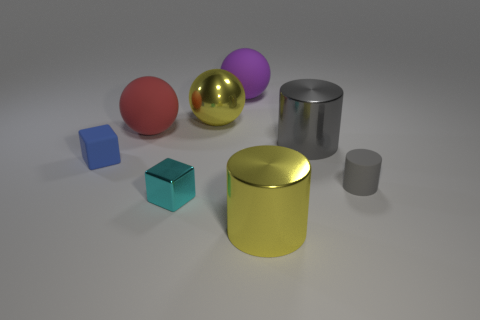Subtract all red balls. How many balls are left? 2 Add 2 tiny brown metal cubes. How many objects exist? 10 Subtract all red balls. How many balls are left? 2 Subtract all brown spheres. How many gray cylinders are left? 2 Subtract all cylinders. How many objects are left? 5 Subtract all purple cylinders. Subtract all green cubes. How many cylinders are left? 3 Subtract all metallic blocks. Subtract all big purple matte objects. How many objects are left? 6 Add 8 tiny gray matte things. How many tiny gray matte things are left? 9 Add 2 tiny blue matte balls. How many tiny blue matte balls exist? 2 Subtract 1 purple balls. How many objects are left? 7 